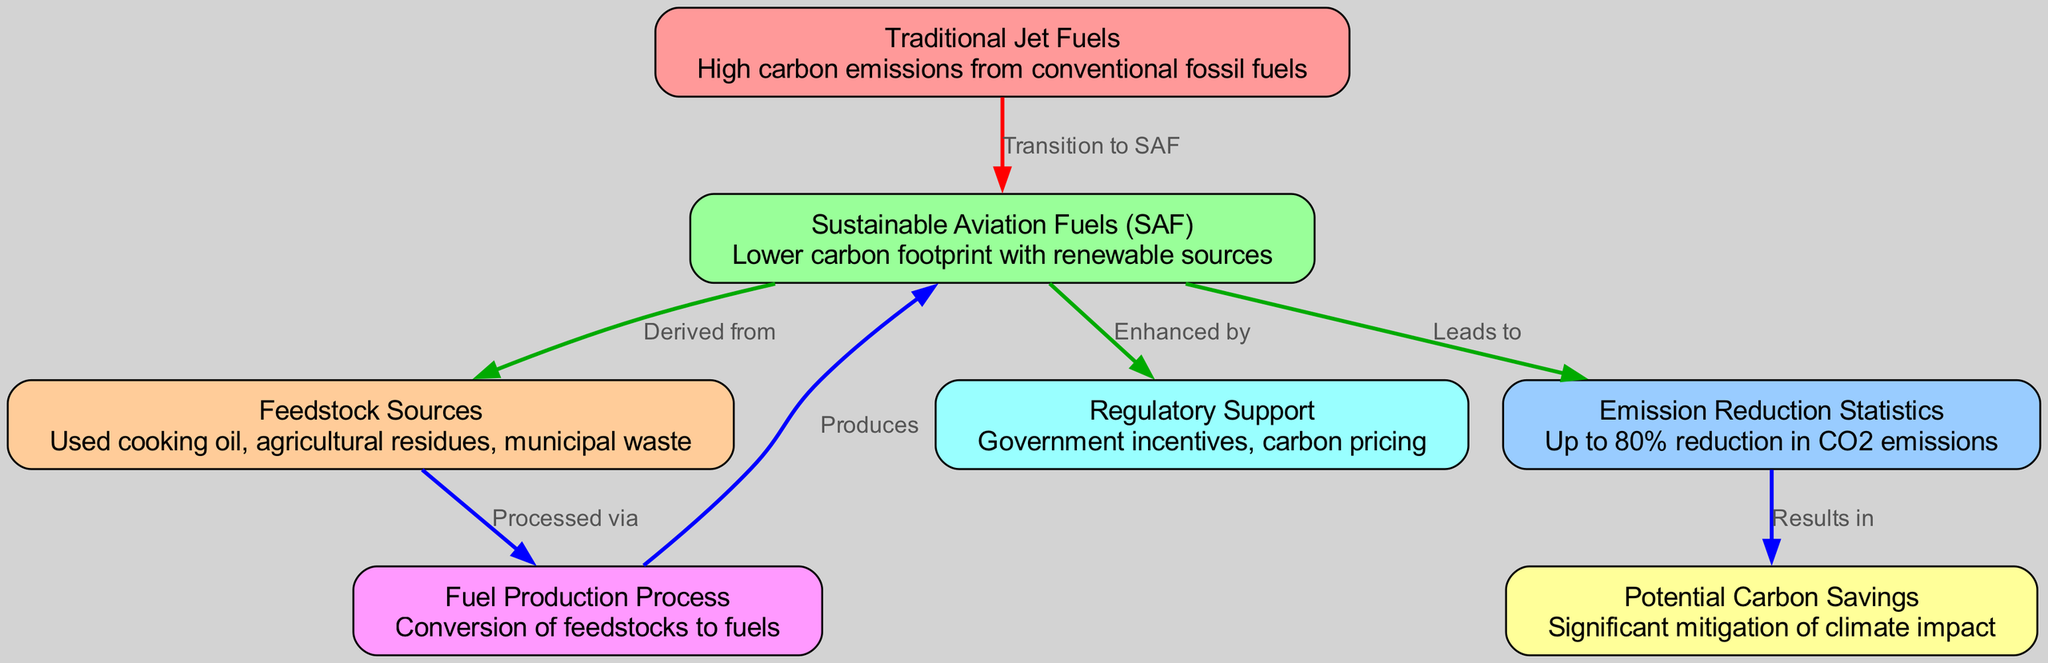What are the feedstock sources for Sustainable Aviation Fuels (SAF)? The diagram clearly states that the feedstock sources for SAF include used cooking oil, agricultural residues, and municipal waste. These are mentioned directly under the node "Feedstock Sources."
Answer: Used cooking oil, agricultural residues, municipal waste What is the emission reduction statistic associated with SAF? According to the "Emission Reduction Statistics" node, the transition to SAF can result in up to an 80% reduction in CO2 emissions. This statistic is explicitly stated in the diagram.
Answer: Up to 80% What leads to significant potential carbon savings? The flow in the diagram indicates that the "Emission Reduction Statistics," which highlight the reduction of CO2 emissions, results in the "Potential Carbon Savings." Thus, the relationship is that the emission reductions lead to potential carbon savings.
Answer: Emission Reduction Statistics How many nodes are present in the diagram? By counting the individual nodes listed in the nodes section of the diagram data, there are a total of 7 nodes in the diagram. Each of these nodes represents a different aspect of SAF and its impact.
Answer: 7 What enhances the adoption of Sustainable Aviation Fuels (SAF)? The diagram indicates that the transition to SAF is "Enhanced by" regulatory support, which includes government incentives and carbon pricing. This relationship is directly shown by the edge connecting these two nodes.
Answer: Regulatory Support Which fuel production process is used to produce Sustainable Aviation Fuels (SAF)? According to the diagram, Sustainable Aviation Fuels (SAF) are produced through a "Fuel Production Process" that involves the conversion of feedstocks. The flow shows that the feedstock sources are processed via this fuel production process.
Answer: Conversion of feedstocks to fuels What is the primary disadvantage of traditional jet fuels? The node for "Traditional Jet Fuels" articulates that these fuels are associated with "High carbon emissions from conventional fossil fuels," indicating their primary environmental disadvantage compared to SAF.
Answer: High carbon emissions What type of fuel is derived from used cooking oil? The diagram specifies that Sustainable Aviation Fuels (SAF) are derived from various feedstock sources including used cooking oil. The edge labeled "Derived from" connects these two nodes, establishing the relationship clearly.
Answer: Sustainable Aviation Fuels (SAF) 